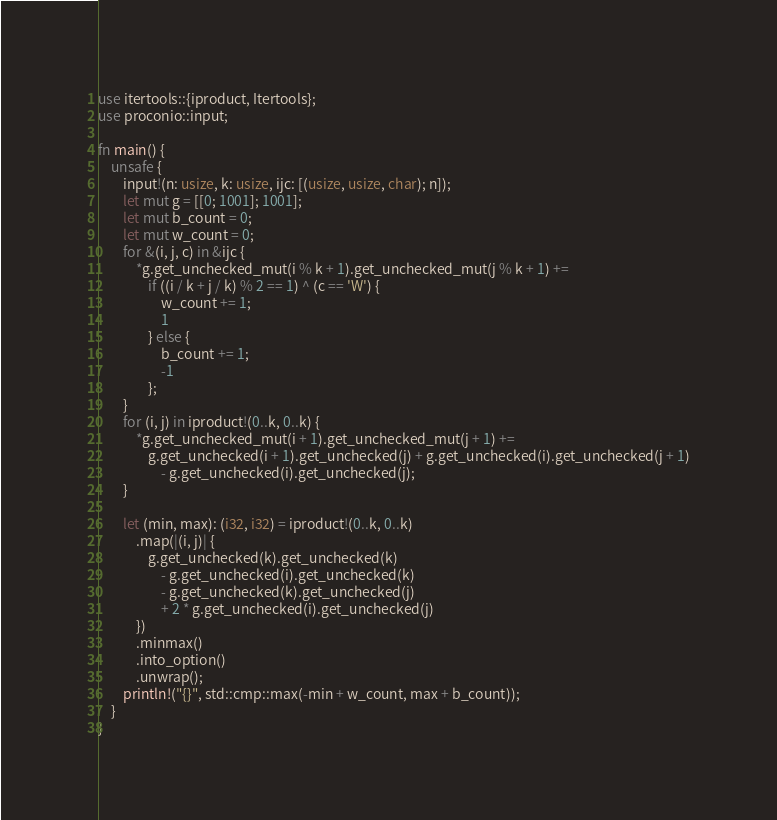<code> <loc_0><loc_0><loc_500><loc_500><_Rust_>use itertools::{iproduct, Itertools};
use proconio::input;

fn main() {
    unsafe {
        input!(n: usize, k: usize, ijc: [(usize, usize, char); n]);
        let mut g = [[0; 1001]; 1001];
        let mut b_count = 0;
        let mut w_count = 0;
        for &(i, j, c) in &ijc {
            *g.get_unchecked_mut(i % k + 1).get_unchecked_mut(j % k + 1) +=
                if ((i / k + j / k) % 2 == 1) ^ (c == 'W') {
                    w_count += 1;
                    1
                } else {
                    b_count += 1;
                    -1
                };
        }
        for (i, j) in iproduct!(0..k, 0..k) {
            *g.get_unchecked_mut(i + 1).get_unchecked_mut(j + 1) +=
                g.get_unchecked(i + 1).get_unchecked(j) + g.get_unchecked(i).get_unchecked(j + 1)
                    - g.get_unchecked(i).get_unchecked(j);
        }

        let (min, max): (i32, i32) = iproduct!(0..k, 0..k)
            .map(|(i, j)| {
                g.get_unchecked(k).get_unchecked(k)
                    - g.get_unchecked(i).get_unchecked(k)
                    - g.get_unchecked(k).get_unchecked(j)
                    + 2 * g.get_unchecked(i).get_unchecked(j)
            })
            .minmax()
            .into_option()
            .unwrap();
        println!("{}", std::cmp::max(-min + w_count, max + b_count));
    }
}
</code> 